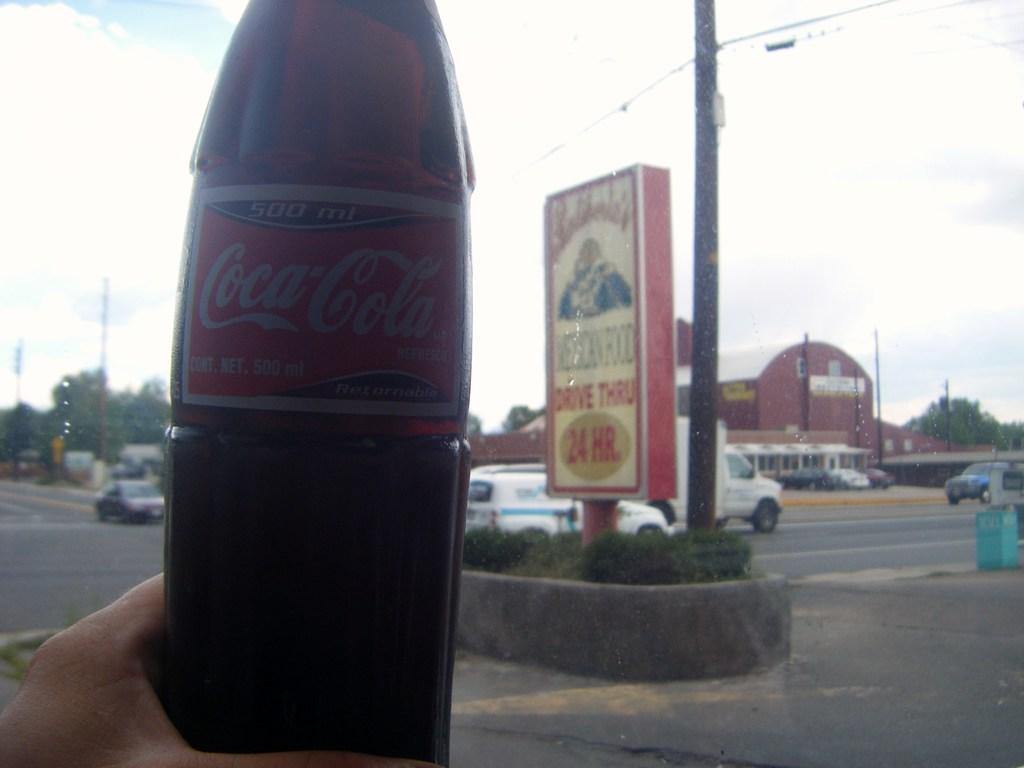<image>
Relay a brief, clear account of the picture shown. A bottle of "Coca-Cola" is in someone's hand. 